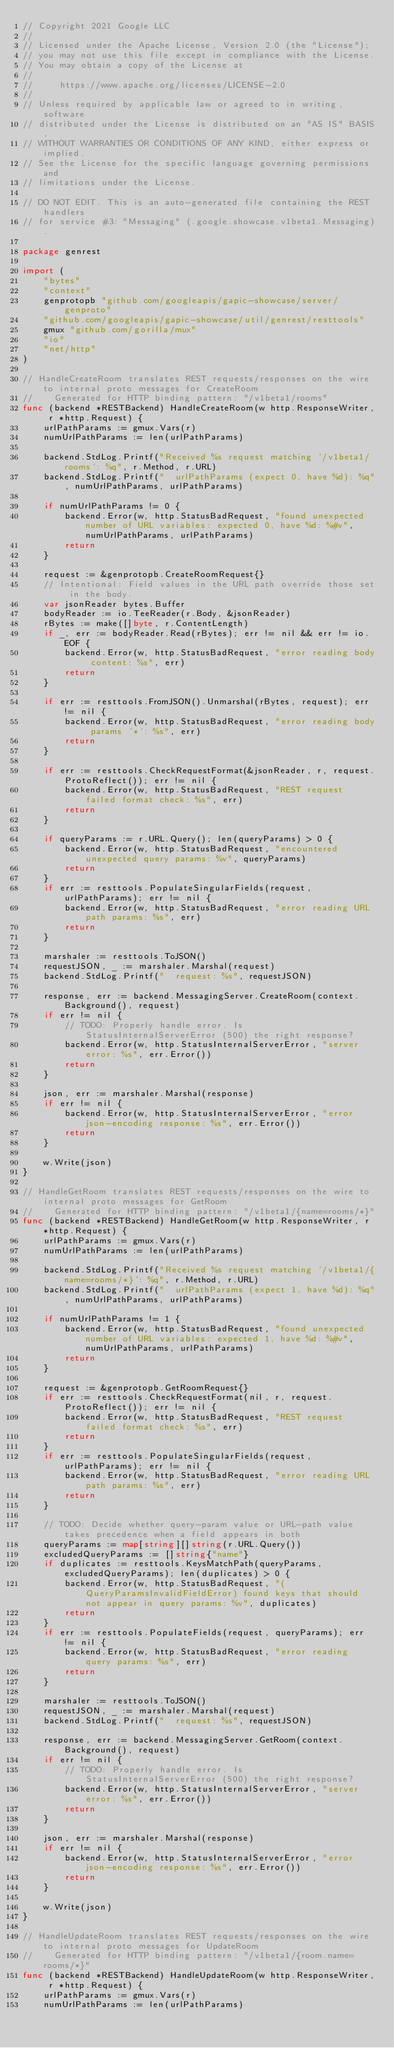Convert code to text. <code><loc_0><loc_0><loc_500><loc_500><_Go_>// Copyright 2021 Google LLC
//
// Licensed under the Apache License, Version 2.0 (the "License");
// you may not use this file except in compliance with the License.
// You may obtain a copy of the License at
//
//     https://www.apache.org/licenses/LICENSE-2.0
//
// Unless required by applicable law or agreed to in writing, software
// distributed under the License is distributed on an "AS IS" BASIS,
// WITHOUT WARRANTIES OR CONDITIONS OF ANY KIND, either express or implied.
// See the License for the specific language governing permissions and
// limitations under the License.

// DO NOT EDIT. This is an auto-generated file containing the REST handlers
// for service #3: "Messaging" (.google.showcase.v1beta1.Messaging).

package genrest

import (
	"bytes"
	"context"
	genprotopb "github.com/googleapis/gapic-showcase/server/genproto"
	"github.com/googleapis/gapic-showcase/util/genrest/resttools"
	gmux "github.com/gorilla/mux"
	"io"
	"net/http"
)

// HandleCreateRoom translates REST requests/responses on the wire to internal proto messages for CreateRoom
//    Generated for HTTP binding pattern: "/v1beta1/rooms"
func (backend *RESTBackend) HandleCreateRoom(w http.ResponseWriter, r *http.Request) {
	urlPathParams := gmux.Vars(r)
	numUrlPathParams := len(urlPathParams)

	backend.StdLog.Printf("Received %s request matching '/v1beta1/rooms': %q", r.Method, r.URL)
	backend.StdLog.Printf("  urlPathParams (expect 0, have %d): %q", numUrlPathParams, urlPathParams)

	if numUrlPathParams != 0 {
		backend.Error(w, http.StatusBadRequest, "found unexpected number of URL variables: expected 0, have %d: %#v", numUrlPathParams, urlPathParams)
		return
	}

	request := &genprotopb.CreateRoomRequest{}
	// Intentional: Field values in the URL path override those set in the body.
	var jsonReader bytes.Buffer
	bodyReader := io.TeeReader(r.Body, &jsonReader)
	rBytes := make([]byte, r.ContentLength)
	if _, err := bodyReader.Read(rBytes); err != nil && err != io.EOF {
		backend.Error(w, http.StatusBadRequest, "error reading body content: %s", err)
		return
	}

	if err := resttools.FromJSON().Unmarshal(rBytes, request); err != nil {
		backend.Error(w, http.StatusBadRequest, "error reading body params '*': %s", err)
		return
	}

	if err := resttools.CheckRequestFormat(&jsonReader, r, request.ProtoReflect()); err != nil {
		backend.Error(w, http.StatusBadRequest, "REST request failed format check: %s", err)
		return
	}

	if queryParams := r.URL.Query(); len(queryParams) > 0 {
		backend.Error(w, http.StatusBadRequest, "encountered unexpected query params: %v", queryParams)
		return
	}
	if err := resttools.PopulateSingularFields(request, urlPathParams); err != nil {
		backend.Error(w, http.StatusBadRequest, "error reading URL path params: %s", err)
		return
	}

	marshaler := resttools.ToJSON()
	requestJSON, _ := marshaler.Marshal(request)
	backend.StdLog.Printf("  request: %s", requestJSON)

	response, err := backend.MessagingServer.CreateRoom(context.Background(), request)
	if err != nil {
		// TODO: Properly handle error. Is StatusInternalServerError (500) the right response?
		backend.Error(w, http.StatusInternalServerError, "server error: %s", err.Error())
		return
	}

	json, err := marshaler.Marshal(response)
	if err != nil {
		backend.Error(w, http.StatusInternalServerError, "error json-encoding response: %s", err.Error())
		return
	}

	w.Write(json)
}

// HandleGetRoom translates REST requests/responses on the wire to internal proto messages for GetRoom
//    Generated for HTTP binding pattern: "/v1beta1/{name=rooms/*}"
func (backend *RESTBackend) HandleGetRoom(w http.ResponseWriter, r *http.Request) {
	urlPathParams := gmux.Vars(r)
	numUrlPathParams := len(urlPathParams)

	backend.StdLog.Printf("Received %s request matching '/v1beta1/{name=rooms/*}': %q", r.Method, r.URL)
	backend.StdLog.Printf("  urlPathParams (expect 1, have %d): %q", numUrlPathParams, urlPathParams)

	if numUrlPathParams != 1 {
		backend.Error(w, http.StatusBadRequest, "found unexpected number of URL variables: expected 1, have %d: %#v", numUrlPathParams, urlPathParams)
		return
	}

	request := &genprotopb.GetRoomRequest{}
	if err := resttools.CheckRequestFormat(nil, r, request.ProtoReflect()); err != nil {
		backend.Error(w, http.StatusBadRequest, "REST request failed format check: %s", err)
		return
	}
	if err := resttools.PopulateSingularFields(request, urlPathParams); err != nil {
		backend.Error(w, http.StatusBadRequest, "error reading URL path params: %s", err)
		return
	}

	// TODO: Decide whether query-param value or URL-path value takes precedence when a field appears in both
	queryParams := map[string][]string(r.URL.Query())
	excludedQueryParams := []string{"name"}
	if duplicates := resttools.KeysMatchPath(queryParams, excludedQueryParams); len(duplicates) > 0 {
		backend.Error(w, http.StatusBadRequest, "(QueryParamsInvalidFieldError) found keys that should not appear in query params: %v", duplicates)
		return
	}
	if err := resttools.PopulateFields(request, queryParams); err != nil {
		backend.Error(w, http.StatusBadRequest, "error reading query params: %s", err)
		return
	}

	marshaler := resttools.ToJSON()
	requestJSON, _ := marshaler.Marshal(request)
	backend.StdLog.Printf("  request: %s", requestJSON)

	response, err := backend.MessagingServer.GetRoom(context.Background(), request)
	if err != nil {
		// TODO: Properly handle error. Is StatusInternalServerError (500) the right response?
		backend.Error(w, http.StatusInternalServerError, "server error: %s", err.Error())
		return
	}

	json, err := marshaler.Marshal(response)
	if err != nil {
		backend.Error(w, http.StatusInternalServerError, "error json-encoding response: %s", err.Error())
		return
	}

	w.Write(json)
}

// HandleUpdateRoom translates REST requests/responses on the wire to internal proto messages for UpdateRoom
//    Generated for HTTP binding pattern: "/v1beta1/{room.name=rooms/*}"
func (backend *RESTBackend) HandleUpdateRoom(w http.ResponseWriter, r *http.Request) {
	urlPathParams := gmux.Vars(r)
	numUrlPathParams := len(urlPathParams)
</code> 